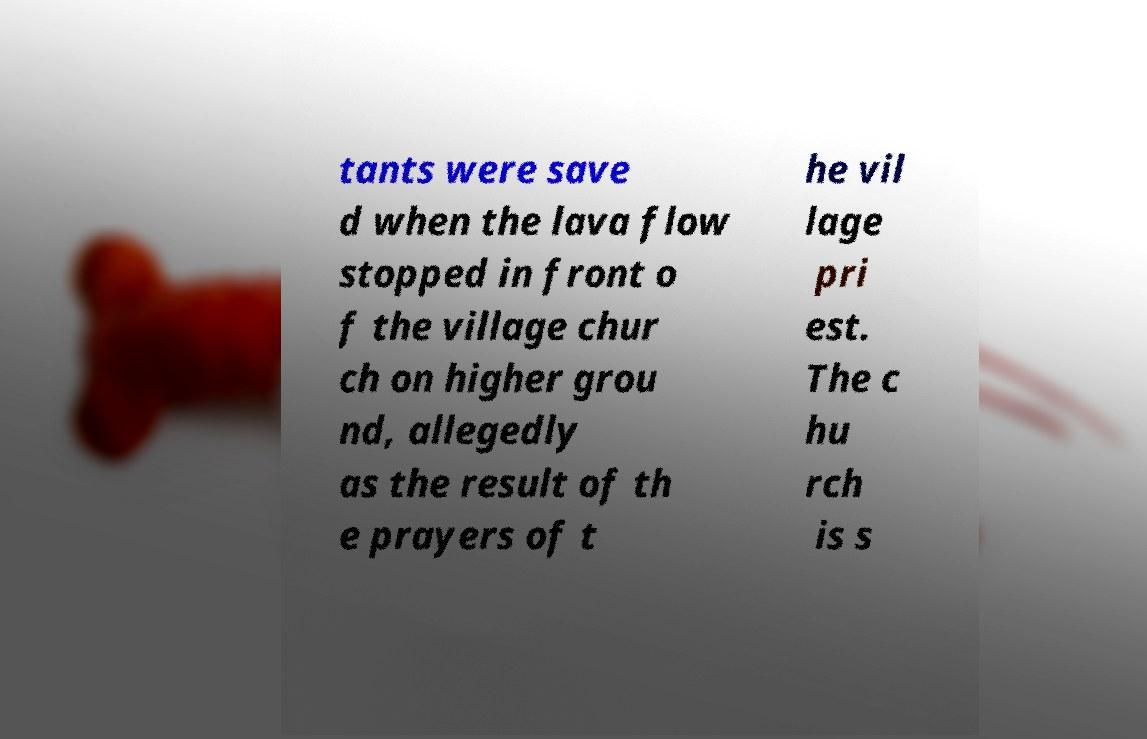Can you accurately transcribe the text from the provided image for me? tants were save d when the lava flow stopped in front o f the village chur ch on higher grou nd, allegedly as the result of th e prayers of t he vil lage pri est. The c hu rch is s 